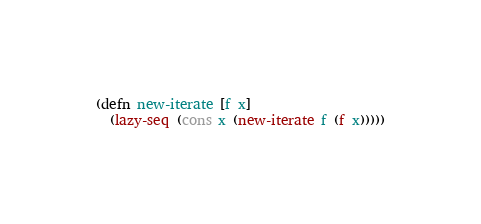<code> <loc_0><loc_0><loc_500><loc_500><_Clojure_>(defn new-iterate [f x]
  (lazy-seq (cons x (new-iterate f (f x)))))
</code> 